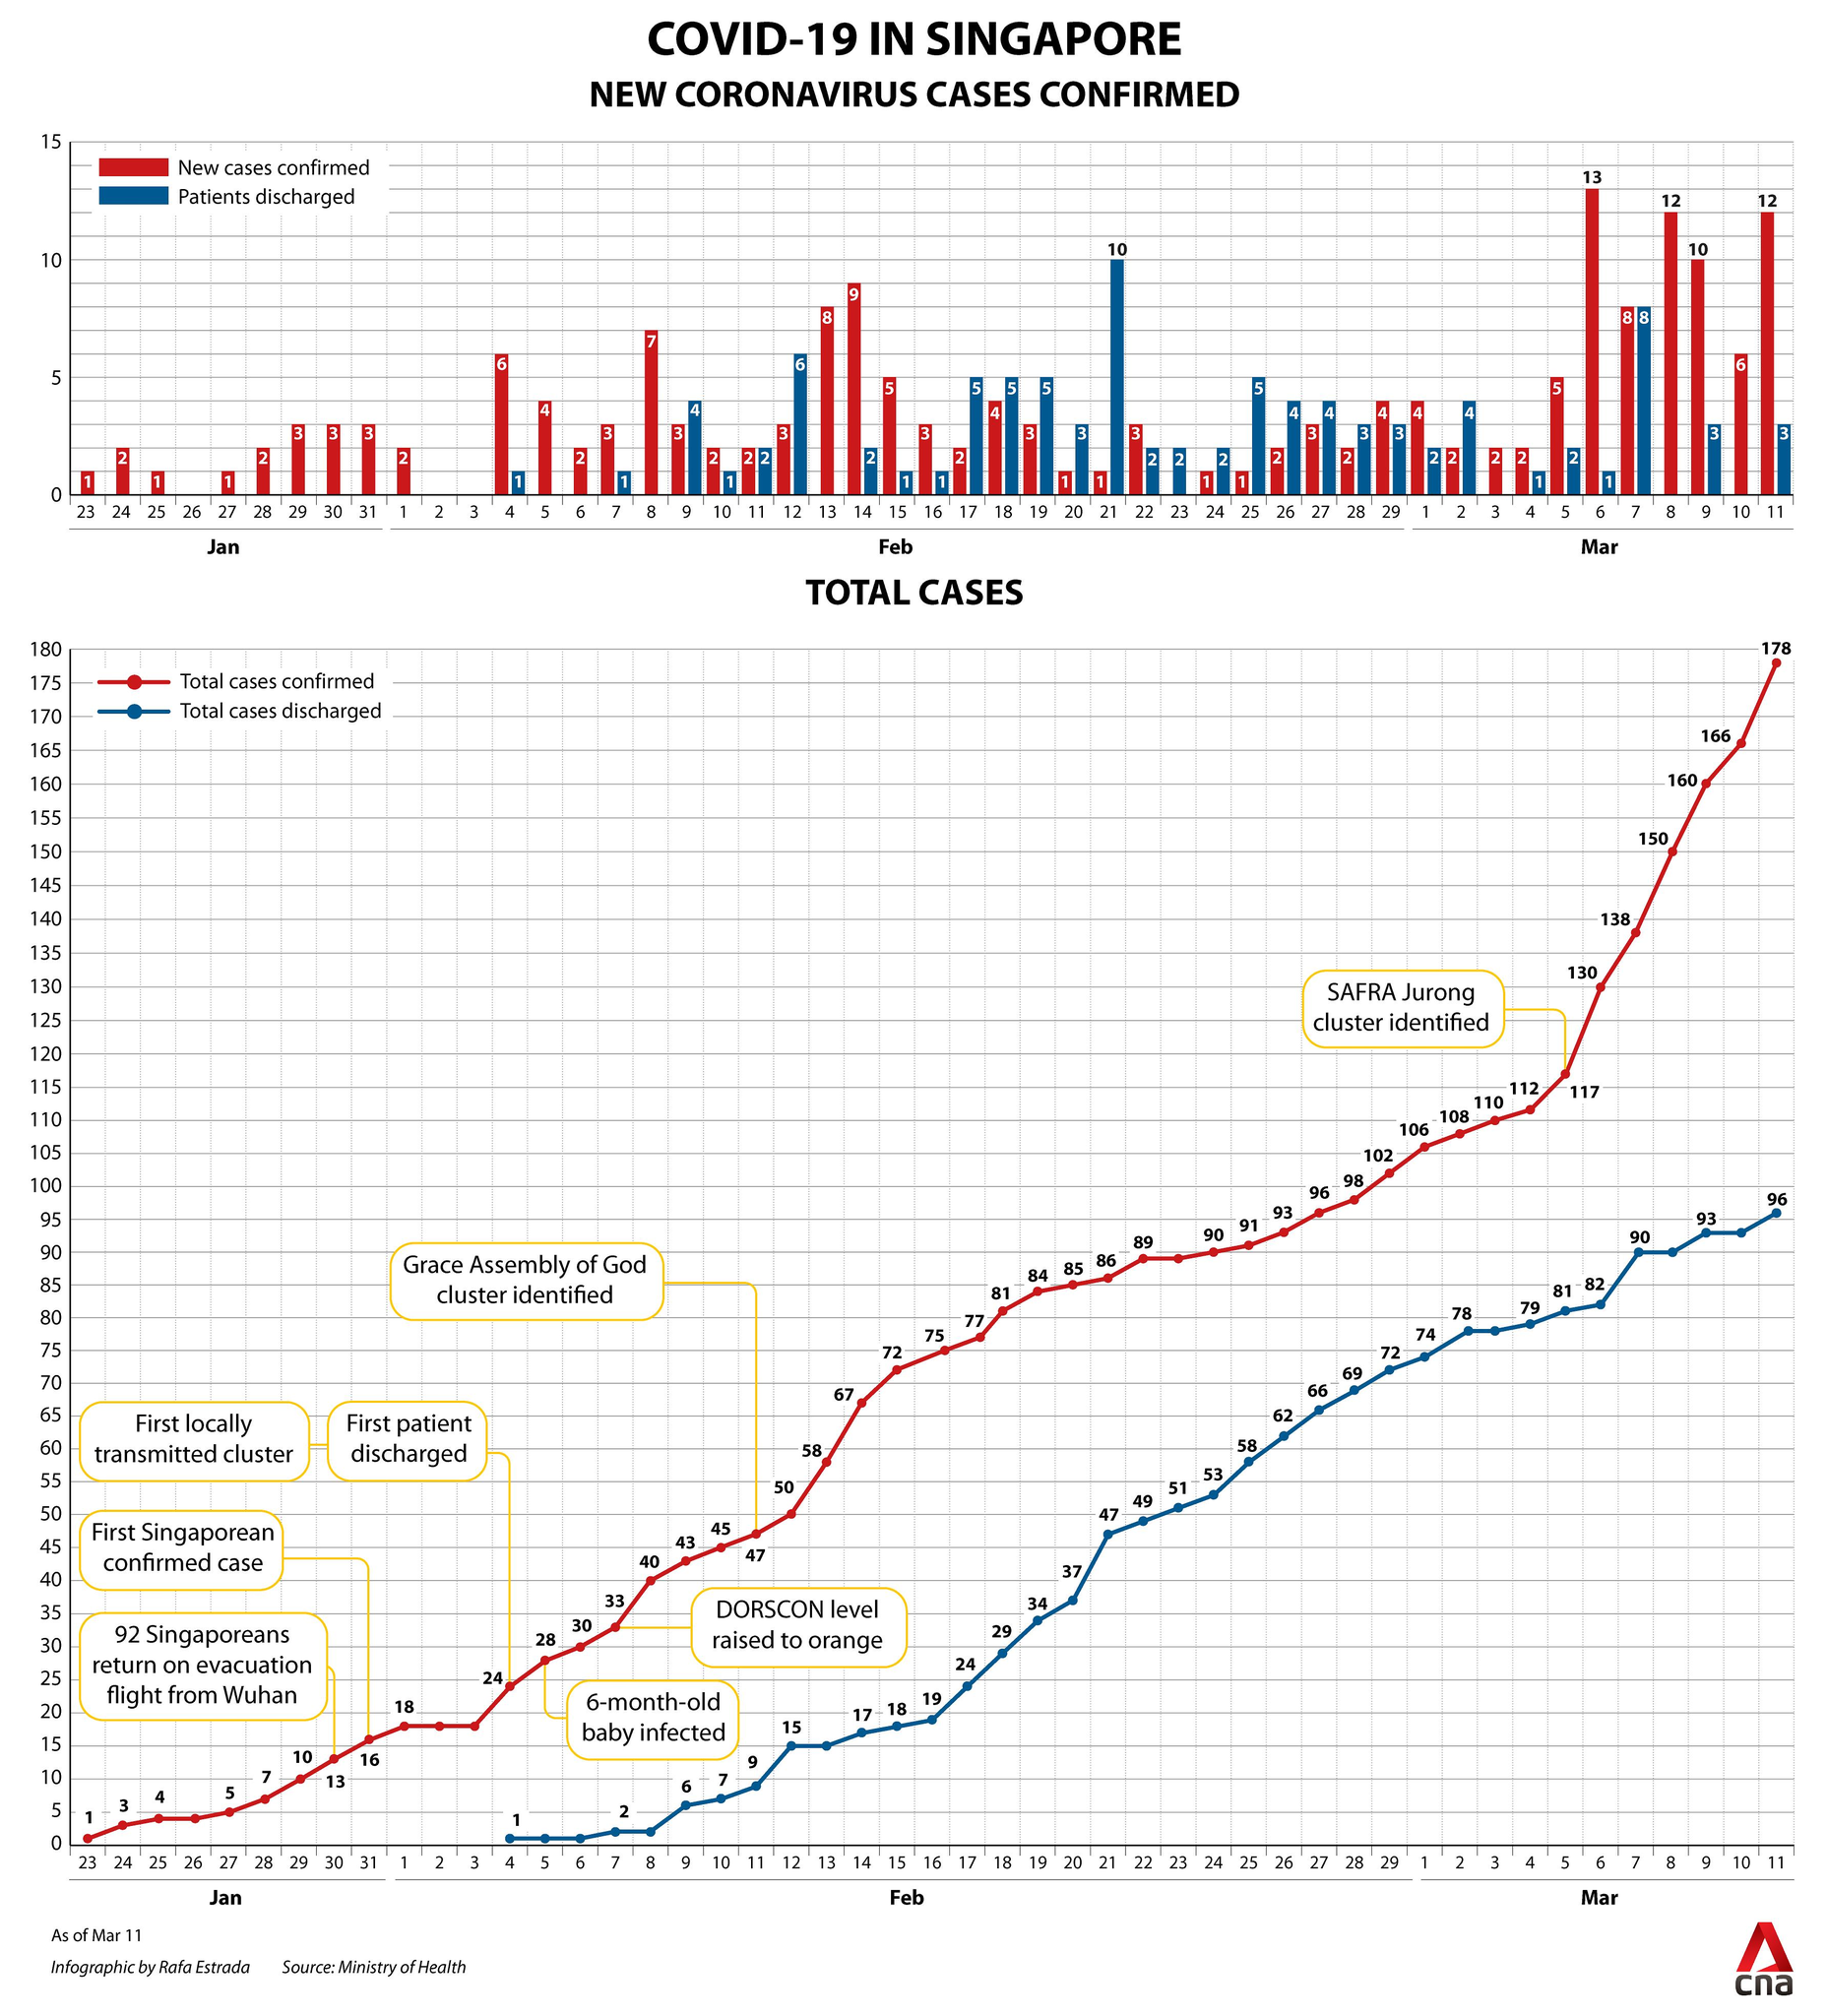Outline some significant characteristics in this image. The number of COVID-19 cases discharged in the month of March in Singapore was the second highest, with a total of 93 cases. On February 4th, the number of total Covid-19 cases discharged in Singapore reached the smallest amount. In the month of February, a total of 72 cases of Covid-19 were discharged in Singapore, representing the highest number of discharges for any month during the pandemic. A total of 117 cases of Covid-19 have been identified in the SAFRA Jurong cluster in Singapore. There were 12 new confirmed cases of Covid-19 in Singapore on March 11. 